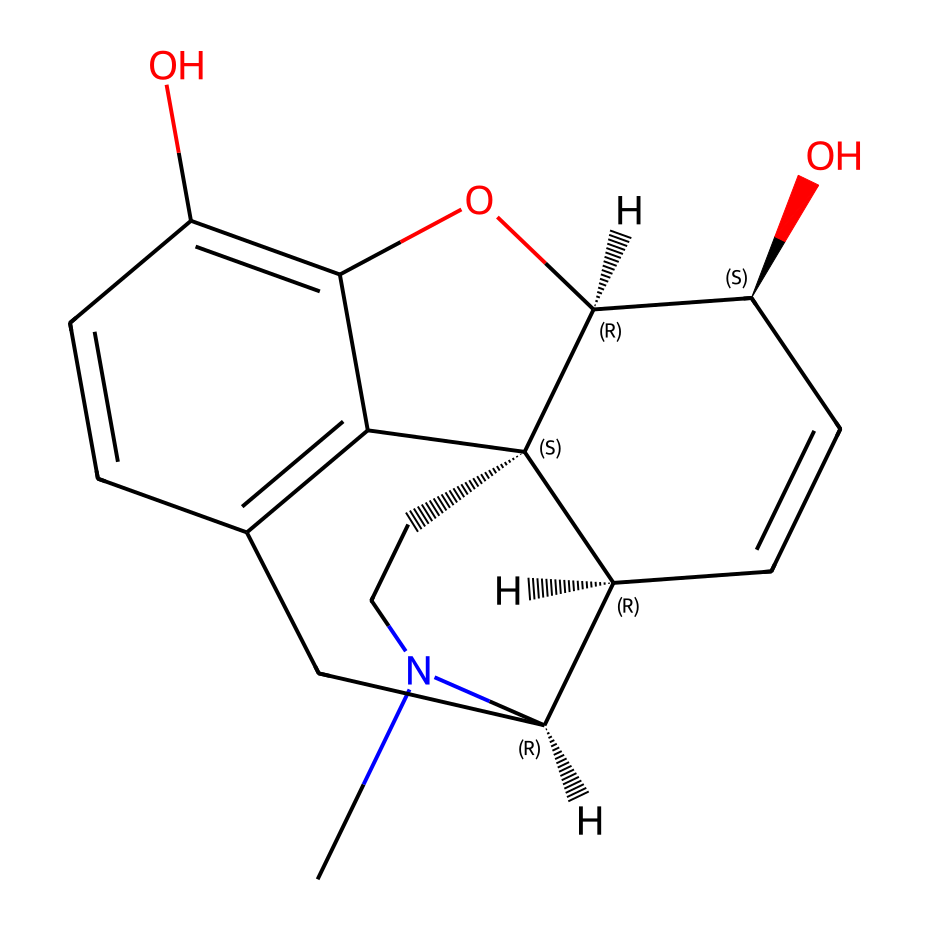What is the molecular formula of morphine? To determine the molecular formula, count all the carbon (C), hydrogen (H), nitrogen (N), and oxygen (O) atoms present in the SMILES notation. The structure shows 17 carbons (C), 19 hydrogens (H), 1 nitrogen (N), and 3 oxygens (O). Therefore, the molecular formula is C17H19N3O3.
Answer: C17H19N3O3 How many rings are present in the structure? By analyzing the SMILES representation, the presence of numerical indicators (1, 2, 3, 4, and 5) indicates multiple cyclic structures. Upon examination, there are five rings present in the chemical structure of morphine.
Answer: 5 What type of isomerism does morphine exhibit? The SMILES notation indicates chiral centers (denoted by '@' symbols), suggesting morphine can exist as enantiomers. Therefore, morphine exhibits structural and stereoisomerism due to these chiral centers.
Answer: stereoisomerism What functional group is primarily responsible for morphine's pharmacological effects? The presence of a hydroxyl (-OH) group in the structure indicates that morphine has phenolic functional groups, which play a critical role in opioid receptor binding and its analgesic properties.
Answer: phenolic What does the nitrogen in morphine signify about its classification? The presence of a nitrogen atom in the structure indicates that morphine is classified as a nitrogen-containing compound, specifically an alkaloid, which is often biologically active and derived from plant sources.
Answer: alkaloid 